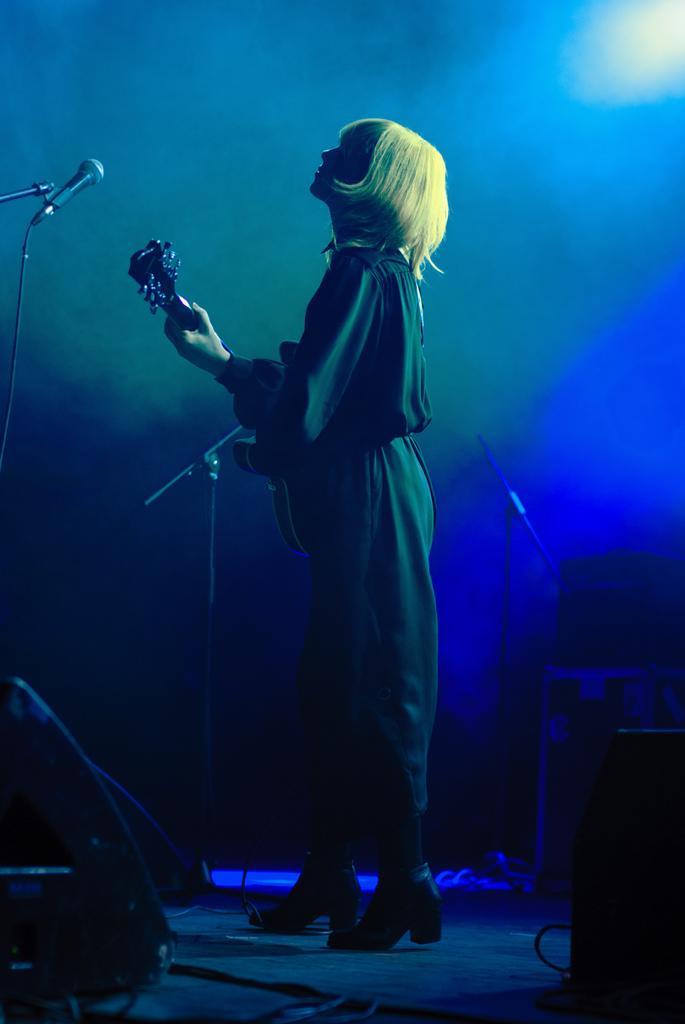In one or two sentences, can you explain what this image depicts? In the image there is a woman, she is playing a guitar and there are some instruments around her and behind the woman a blue light is focusing on her. 